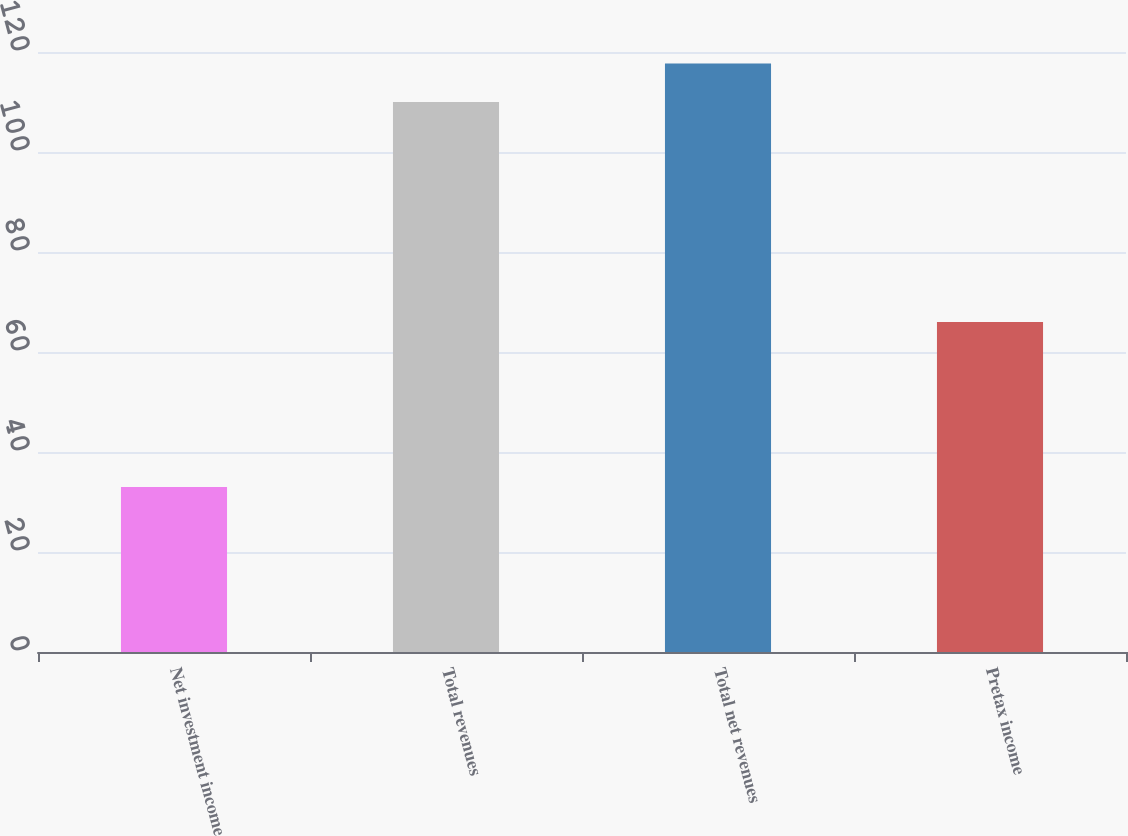Convert chart. <chart><loc_0><loc_0><loc_500><loc_500><bar_chart><fcel>Net investment income<fcel>Total revenues<fcel>Total net revenues<fcel>Pretax income<nl><fcel>33<fcel>110<fcel>117.7<fcel>66<nl></chart> 